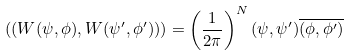<formula> <loc_0><loc_0><loc_500><loc_500>( ( W ( \psi , \phi ) , W ( \psi ^ { \prime } , \phi ^ { \prime } ) ) ) = \left ( \frac { 1 } { 2 \pi } \right ) ^ { N } ( \psi , \psi ^ { \prime } ) \overline { ( \phi , \phi ^ { \prime } ) }</formula> 